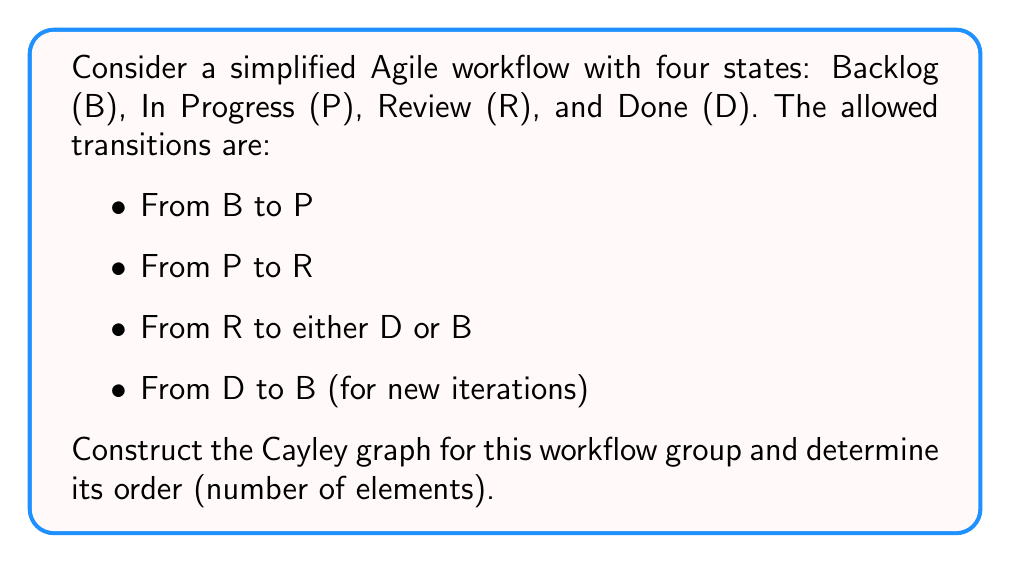Help me with this question. To analyze this workflow as a Cayley graph:

1) First, identify the generators:
   Let a = transition from B to P
   Let b = transition from P to R
   Let c = transition from R to D
   Let d = transition from R to B
   Let e = transition from D to B

2) The relations between these generators:
   $ab$ = transition from B to R
   $abc$ = transition from B to D
   $abce$ = full cycle from B to B through D
   $abd$ = cycle from B to B through R

3) Construct the Cayley graph:
   [asy]
   unitsize(1cm);
   
   pair B = (0,0), P = (2,0), R = (1,1.7), D = (0,1);
   
   draw(B--P--R--D--B);
   draw(R--B);
   
   dot(B); dot(P); dot(R); dot(D);
   
   label("B", B, SW);
   label("P", P, SE);
   label("R", R, N);
   label("D", D, NW);
   
   draw(arc(B,0.3,0,90), arrow=Arrow());
   draw(arc(P,0.3,90,180), arrow=Arrow());
   draw(arc(R,0.3,180,270), arrow=Arrow());
   draw(arc(D,0.3,270,360), arrow=Arrow());
   draw(R--B, arrow=Arrow());
   
   label("a", (B+P)/2, S);
   label("b", (P+R)/2, E);
   label("c", (R+D)/2, NW);
   label("d", (R+B)/2, W);
   label("e", (D+B)/2, W);
   [/asy]

4) Analyze the group structure:
   - The identity element is staying in the same state.
   - Each transition is its own inverse (e.g., $a^2 = id$).
   - The group is generated by {a, b, c, d, e}.
   - All elements can be written as products of these generators.

5) Determine the order of the group:
   - There are 4 possible states (B, P, R, D).
   - For each state, we can either stay or transition to another state.
   - This gives us 4 choices for each of the 4 states.
   - Therefore, the total number of possible configurations is $4^4 = 256$.

The order of the group is thus 256.
Answer: 256 